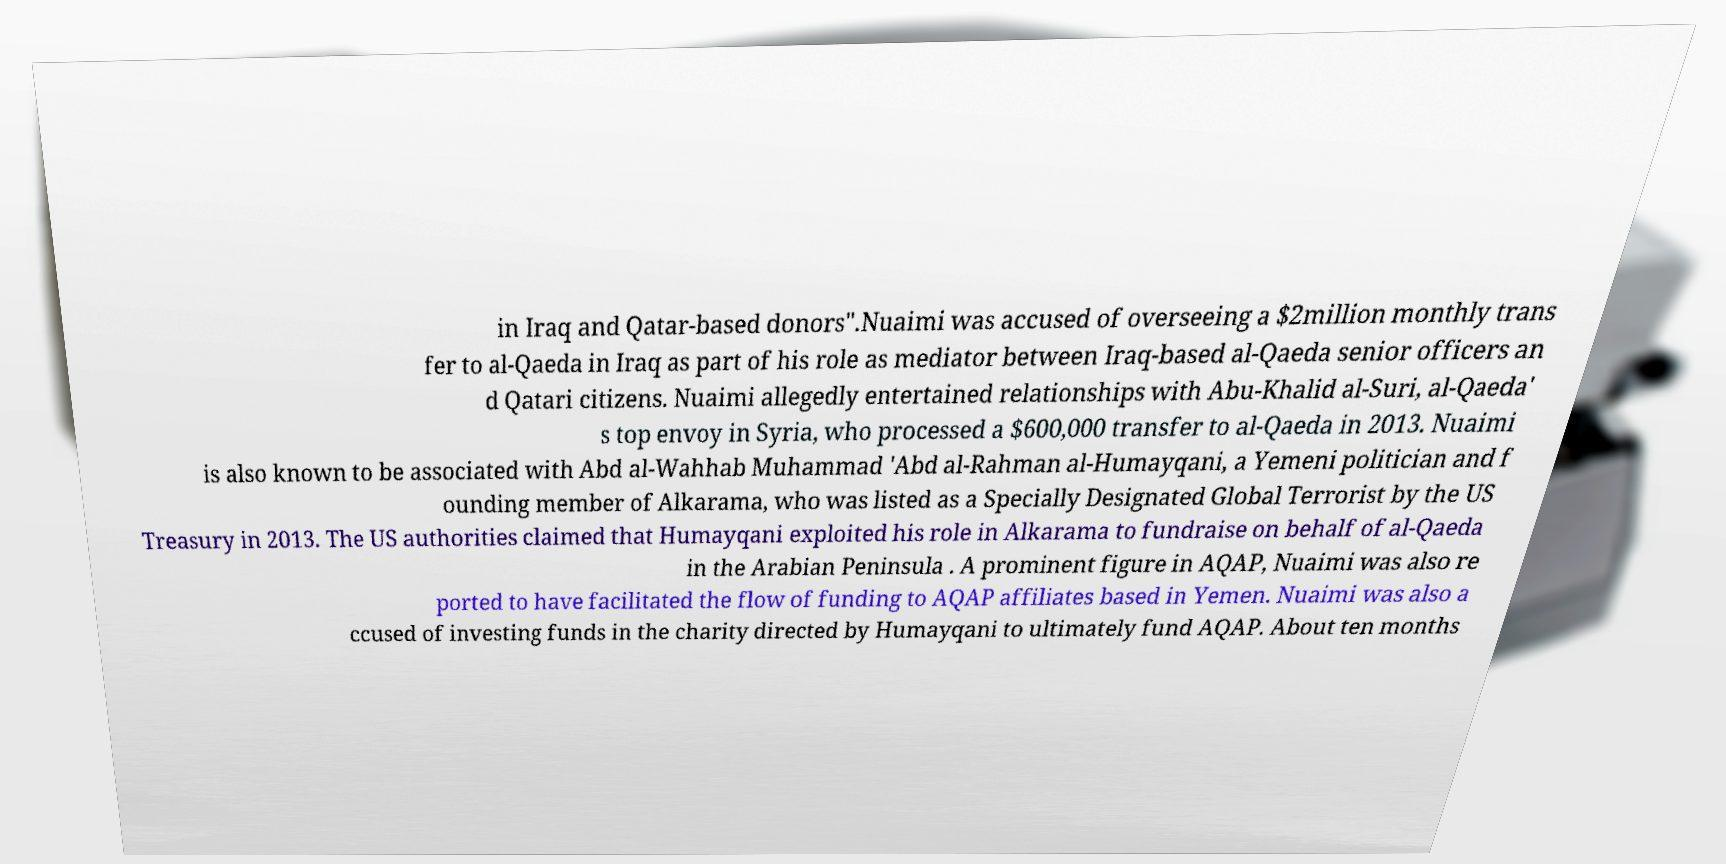Could you assist in decoding the text presented in this image and type it out clearly? in Iraq and Qatar-based donors".Nuaimi was accused of overseeing a $2million monthly trans fer to al-Qaeda in Iraq as part of his role as mediator between Iraq-based al-Qaeda senior officers an d Qatari citizens. Nuaimi allegedly entertained relationships with Abu-Khalid al-Suri, al-Qaeda' s top envoy in Syria, who processed a $600,000 transfer to al-Qaeda in 2013. Nuaimi is also known to be associated with Abd al-Wahhab Muhammad 'Abd al-Rahman al-Humayqani, a Yemeni politician and f ounding member of Alkarama, who was listed as a Specially Designated Global Terrorist by the US Treasury in 2013. The US authorities claimed that Humayqani exploited his role in Alkarama to fundraise on behalf of al-Qaeda in the Arabian Peninsula . A prominent figure in AQAP, Nuaimi was also re ported to have facilitated the flow of funding to AQAP affiliates based in Yemen. Nuaimi was also a ccused of investing funds in the charity directed by Humayqani to ultimately fund AQAP. About ten months 